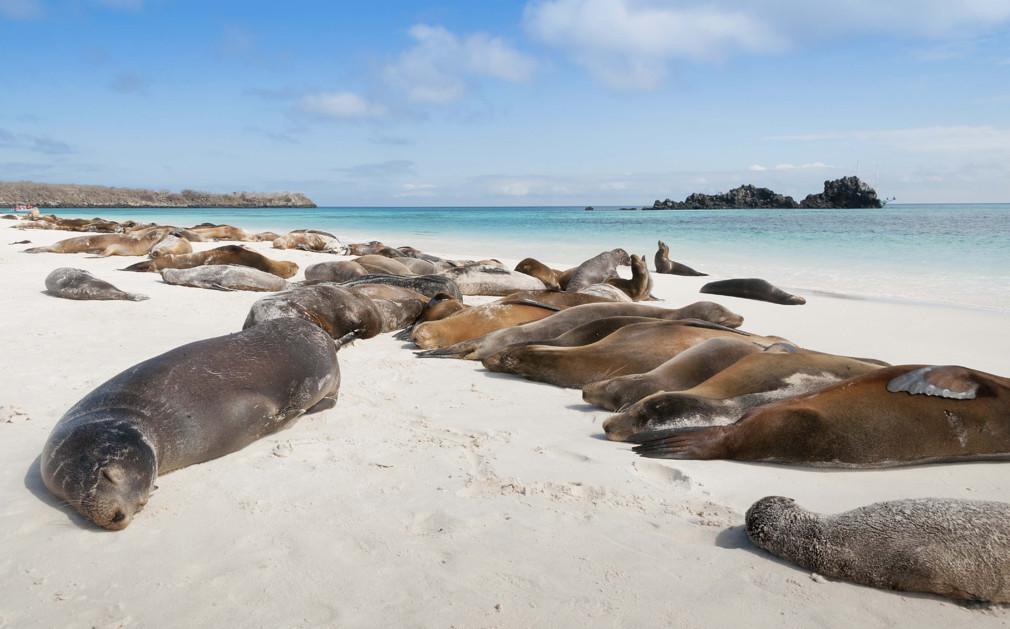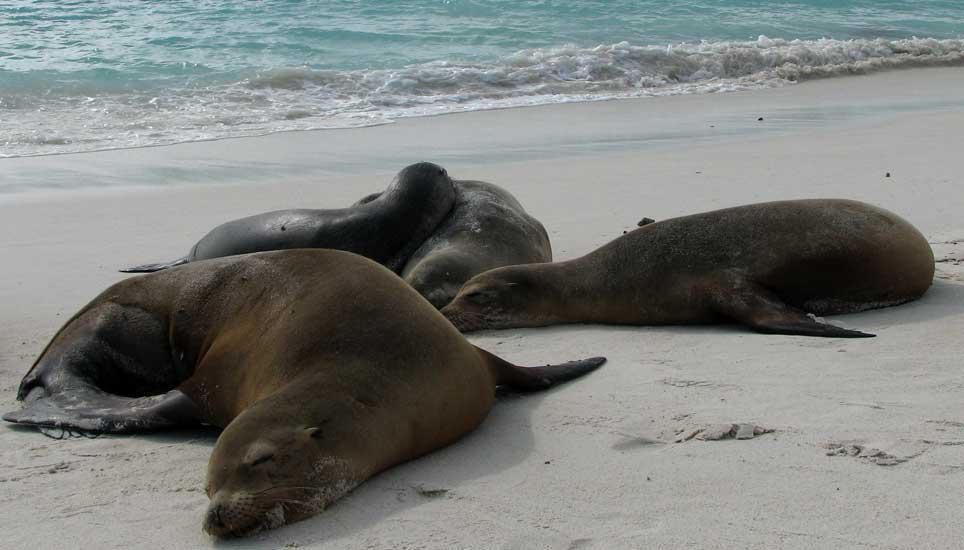The first image is the image on the left, the second image is the image on the right. Assess this claim about the two images: "One image contains no more than two seals, who lie horizontally on the beach, and the other image shows seals lying lengthwise, head-first on the beach.". Correct or not? Answer yes or no. No. The first image is the image on the left, the second image is the image on the right. Considering the images on both sides, is "Two seals are lying in the sand in the image on the right." valid? Answer yes or no. No. 